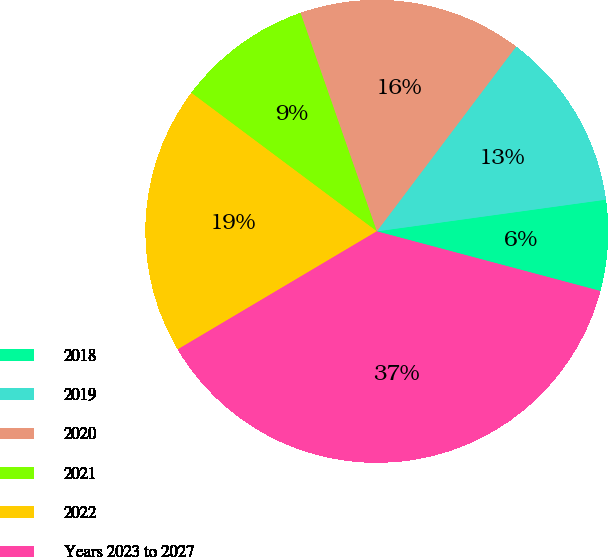<chart> <loc_0><loc_0><loc_500><loc_500><pie_chart><fcel>2018<fcel>2019<fcel>2020<fcel>2021<fcel>2022<fcel>Years 2023 to 2027<nl><fcel>6.34%<fcel>12.53%<fcel>15.63%<fcel>9.44%<fcel>18.73%<fcel>37.33%<nl></chart> 